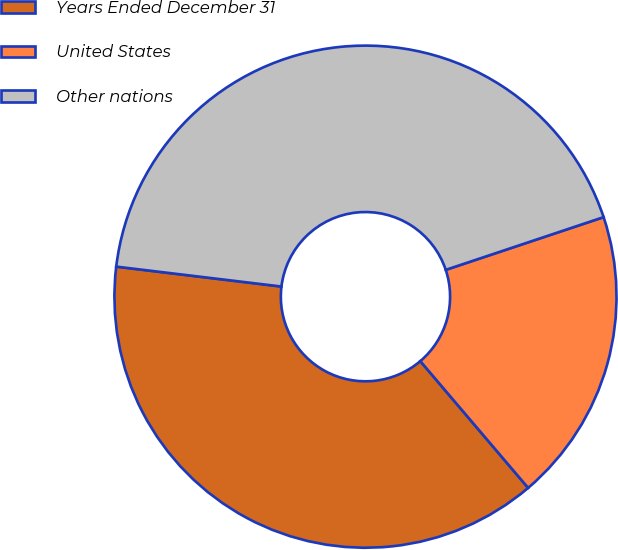<chart> <loc_0><loc_0><loc_500><loc_500><pie_chart><fcel>Years Ended December 31<fcel>United States<fcel>Other nations<nl><fcel>38.13%<fcel>18.91%<fcel>42.96%<nl></chart> 